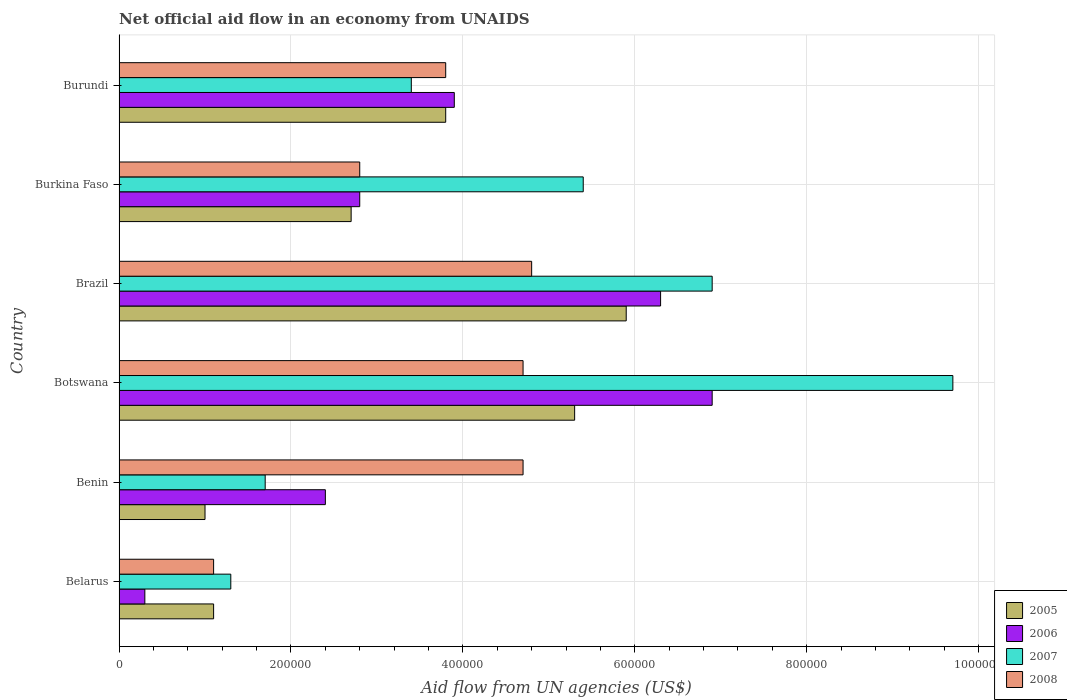How many groups of bars are there?
Offer a terse response. 6. How many bars are there on the 6th tick from the top?
Your response must be concise. 4. What is the label of the 3rd group of bars from the top?
Make the answer very short. Brazil. What is the net official aid flow in 2007 in Belarus?
Provide a short and direct response. 1.30e+05. Across all countries, what is the maximum net official aid flow in 2006?
Provide a succinct answer. 6.90e+05. In which country was the net official aid flow in 2006 maximum?
Offer a terse response. Botswana. In which country was the net official aid flow in 2008 minimum?
Make the answer very short. Belarus. What is the total net official aid flow in 2007 in the graph?
Make the answer very short. 2.84e+06. What is the difference between the net official aid flow in 2006 in Benin and that in Brazil?
Give a very brief answer. -3.90e+05. What is the difference between the net official aid flow in 2008 and net official aid flow in 2007 in Botswana?
Your response must be concise. -5.00e+05. What is the ratio of the net official aid flow in 2006 in Belarus to that in Burundi?
Provide a succinct answer. 0.08. Is the net official aid flow in 2006 in Botswana less than that in Burkina Faso?
Offer a terse response. No. What is the difference between the highest and the lowest net official aid flow in 2007?
Offer a very short reply. 8.40e+05. In how many countries, is the net official aid flow in 2006 greater than the average net official aid flow in 2006 taken over all countries?
Ensure brevity in your answer.  3. Is the sum of the net official aid flow in 2006 in Belarus and Benin greater than the maximum net official aid flow in 2005 across all countries?
Keep it short and to the point. No. Is it the case that in every country, the sum of the net official aid flow in 2007 and net official aid flow in 2006 is greater than the sum of net official aid flow in 2005 and net official aid flow in 2008?
Your answer should be compact. No. What does the 4th bar from the top in Belarus represents?
Ensure brevity in your answer.  2005. Is it the case that in every country, the sum of the net official aid flow in 2006 and net official aid flow in 2005 is greater than the net official aid flow in 2008?
Provide a short and direct response. No. How many bars are there?
Make the answer very short. 24. What is the difference between two consecutive major ticks on the X-axis?
Your answer should be compact. 2.00e+05. Are the values on the major ticks of X-axis written in scientific E-notation?
Keep it short and to the point. No. Does the graph contain any zero values?
Your answer should be very brief. No. How many legend labels are there?
Give a very brief answer. 4. What is the title of the graph?
Your answer should be very brief. Net official aid flow in an economy from UNAIDS. What is the label or title of the X-axis?
Your answer should be very brief. Aid flow from UN agencies (US$). What is the label or title of the Y-axis?
Make the answer very short. Country. What is the Aid flow from UN agencies (US$) of 2005 in Benin?
Make the answer very short. 1.00e+05. What is the Aid flow from UN agencies (US$) in 2005 in Botswana?
Your answer should be compact. 5.30e+05. What is the Aid flow from UN agencies (US$) in 2006 in Botswana?
Ensure brevity in your answer.  6.90e+05. What is the Aid flow from UN agencies (US$) of 2007 in Botswana?
Ensure brevity in your answer.  9.70e+05. What is the Aid flow from UN agencies (US$) of 2005 in Brazil?
Make the answer very short. 5.90e+05. What is the Aid flow from UN agencies (US$) in 2006 in Brazil?
Provide a succinct answer. 6.30e+05. What is the Aid flow from UN agencies (US$) in 2007 in Brazil?
Give a very brief answer. 6.90e+05. What is the Aid flow from UN agencies (US$) of 2007 in Burkina Faso?
Make the answer very short. 5.40e+05. What is the Aid flow from UN agencies (US$) in 2005 in Burundi?
Your response must be concise. 3.80e+05. What is the Aid flow from UN agencies (US$) in 2006 in Burundi?
Your answer should be very brief. 3.90e+05. What is the Aid flow from UN agencies (US$) of 2008 in Burundi?
Your response must be concise. 3.80e+05. Across all countries, what is the maximum Aid flow from UN agencies (US$) in 2005?
Provide a succinct answer. 5.90e+05. Across all countries, what is the maximum Aid flow from UN agencies (US$) in 2006?
Keep it short and to the point. 6.90e+05. Across all countries, what is the maximum Aid flow from UN agencies (US$) in 2007?
Provide a succinct answer. 9.70e+05. Across all countries, what is the minimum Aid flow from UN agencies (US$) in 2005?
Make the answer very short. 1.00e+05. Across all countries, what is the minimum Aid flow from UN agencies (US$) in 2007?
Your answer should be compact. 1.30e+05. What is the total Aid flow from UN agencies (US$) of 2005 in the graph?
Your answer should be very brief. 1.98e+06. What is the total Aid flow from UN agencies (US$) of 2006 in the graph?
Offer a very short reply. 2.26e+06. What is the total Aid flow from UN agencies (US$) of 2007 in the graph?
Your answer should be very brief. 2.84e+06. What is the total Aid flow from UN agencies (US$) in 2008 in the graph?
Your answer should be very brief. 2.19e+06. What is the difference between the Aid flow from UN agencies (US$) in 2005 in Belarus and that in Benin?
Offer a very short reply. 10000. What is the difference between the Aid flow from UN agencies (US$) in 2007 in Belarus and that in Benin?
Provide a short and direct response. -4.00e+04. What is the difference between the Aid flow from UN agencies (US$) of 2008 in Belarus and that in Benin?
Offer a terse response. -3.60e+05. What is the difference between the Aid flow from UN agencies (US$) in 2005 in Belarus and that in Botswana?
Offer a terse response. -4.20e+05. What is the difference between the Aid flow from UN agencies (US$) of 2006 in Belarus and that in Botswana?
Provide a short and direct response. -6.60e+05. What is the difference between the Aid flow from UN agencies (US$) of 2007 in Belarus and that in Botswana?
Your response must be concise. -8.40e+05. What is the difference between the Aid flow from UN agencies (US$) in 2008 in Belarus and that in Botswana?
Give a very brief answer. -3.60e+05. What is the difference between the Aid flow from UN agencies (US$) in 2005 in Belarus and that in Brazil?
Your answer should be very brief. -4.80e+05. What is the difference between the Aid flow from UN agencies (US$) of 2006 in Belarus and that in Brazil?
Give a very brief answer. -6.00e+05. What is the difference between the Aid flow from UN agencies (US$) of 2007 in Belarus and that in Brazil?
Make the answer very short. -5.60e+05. What is the difference between the Aid flow from UN agencies (US$) of 2008 in Belarus and that in Brazil?
Ensure brevity in your answer.  -3.70e+05. What is the difference between the Aid flow from UN agencies (US$) of 2005 in Belarus and that in Burkina Faso?
Offer a very short reply. -1.60e+05. What is the difference between the Aid flow from UN agencies (US$) of 2006 in Belarus and that in Burkina Faso?
Provide a succinct answer. -2.50e+05. What is the difference between the Aid flow from UN agencies (US$) of 2007 in Belarus and that in Burkina Faso?
Provide a short and direct response. -4.10e+05. What is the difference between the Aid flow from UN agencies (US$) in 2008 in Belarus and that in Burkina Faso?
Your answer should be compact. -1.70e+05. What is the difference between the Aid flow from UN agencies (US$) in 2005 in Belarus and that in Burundi?
Offer a terse response. -2.70e+05. What is the difference between the Aid flow from UN agencies (US$) of 2006 in Belarus and that in Burundi?
Keep it short and to the point. -3.60e+05. What is the difference between the Aid flow from UN agencies (US$) in 2007 in Belarus and that in Burundi?
Your answer should be very brief. -2.10e+05. What is the difference between the Aid flow from UN agencies (US$) of 2008 in Belarus and that in Burundi?
Your response must be concise. -2.70e+05. What is the difference between the Aid flow from UN agencies (US$) in 2005 in Benin and that in Botswana?
Provide a short and direct response. -4.30e+05. What is the difference between the Aid flow from UN agencies (US$) in 2006 in Benin and that in Botswana?
Provide a succinct answer. -4.50e+05. What is the difference between the Aid flow from UN agencies (US$) of 2007 in Benin and that in Botswana?
Provide a short and direct response. -8.00e+05. What is the difference between the Aid flow from UN agencies (US$) of 2005 in Benin and that in Brazil?
Provide a short and direct response. -4.90e+05. What is the difference between the Aid flow from UN agencies (US$) of 2006 in Benin and that in Brazil?
Your answer should be very brief. -3.90e+05. What is the difference between the Aid flow from UN agencies (US$) of 2007 in Benin and that in Brazil?
Give a very brief answer. -5.20e+05. What is the difference between the Aid flow from UN agencies (US$) in 2007 in Benin and that in Burkina Faso?
Keep it short and to the point. -3.70e+05. What is the difference between the Aid flow from UN agencies (US$) in 2008 in Benin and that in Burkina Faso?
Provide a succinct answer. 1.90e+05. What is the difference between the Aid flow from UN agencies (US$) of 2005 in Benin and that in Burundi?
Ensure brevity in your answer.  -2.80e+05. What is the difference between the Aid flow from UN agencies (US$) in 2006 in Botswana and that in Brazil?
Provide a succinct answer. 6.00e+04. What is the difference between the Aid flow from UN agencies (US$) of 2008 in Botswana and that in Burkina Faso?
Offer a terse response. 1.90e+05. What is the difference between the Aid flow from UN agencies (US$) in 2005 in Botswana and that in Burundi?
Ensure brevity in your answer.  1.50e+05. What is the difference between the Aid flow from UN agencies (US$) of 2007 in Botswana and that in Burundi?
Provide a short and direct response. 6.30e+05. What is the difference between the Aid flow from UN agencies (US$) in 2008 in Botswana and that in Burundi?
Ensure brevity in your answer.  9.00e+04. What is the difference between the Aid flow from UN agencies (US$) of 2005 in Brazil and that in Burkina Faso?
Ensure brevity in your answer.  3.20e+05. What is the difference between the Aid flow from UN agencies (US$) in 2007 in Brazil and that in Burkina Faso?
Provide a succinct answer. 1.50e+05. What is the difference between the Aid flow from UN agencies (US$) in 2005 in Brazil and that in Burundi?
Your answer should be compact. 2.10e+05. What is the difference between the Aid flow from UN agencies (US$) in 2007 in Brazil and that in Burundi?
Ensure brevity in your answer.  3.50e+05. What is the difference between the Aid flow from UN agencies (US$) in 2005 in Burkina Faso and that in Burundi?
Your answer should be very brief. -1.10e+05. What is the difference between the Aid flow from UN agencies (US$) in 2005 in Belarus and the Aid flow from UN agencies (US$) in 2006 in Benin?
Offer a terse response. -1.30e+05. What is the difference between the Aid flow from UN agencies (US$) of 2005 in Belarus and the Aid flow from UN agencies (US$) of 2007 in Benin?
Offer a very short reply. -6.00e+04. What is the difference between the Aid flow from UN agencies (US$) of 2005 in Belarus and the Aid flow from UN agencies (US$) of 2008 in Benin?
Offer a very short reply. -3.60e+05. What is the difference between the Aid flow from UN agencies (US$) of 2006 in Belarus and the Aid flow from UN agencies (US$) of 2008 in Benin?
Keep it short and to the point. -4.40e+05. What is the difference between the Aid flow from UN agencies (US$) in 2005 in Belarus and the Aid flow from UN agencies (US$) in 2006 in Botswana?
Offer a very short reply. -5.80e+05. What is the difference between the Aid flow from UN agencies (US$) in 2005 in Belarus and the Aid flow from UN agencies (US$) in 2007 in Botswana?
Provide a succinct answer. -8.60e+05. What is the difference between the Aid flow from UN agencies (US$) of 2005 in Belarus and the Aid flow from UN agencies (US$) of 2008 in Botswana?
Your answer should be very brief. -3.60e+05. What is the difference between the Aid flow from UN agencies (US$) in 2006 in Belarus and the Aid flow from UN agencies (US$) in 2007 in Botswana?
Provide a succinct answer. -9.40e+05. What is the difference between the Aid flow from UN agencies (US$) in 2006 in Belarus and the Aid flow from UN agencies (US$) in 2008 in Botswana?
Offer a terse response. -4.40e+05. What is the difference between the Aid flow from UN agencies (US$) of 2007 in Belarus and the Aid flow from UN agencies (US$) of 2008 in Botswana?
Provide a succinct answer. -3.40e+05. What is the difference between the Aid flow from UN agencies (US$) in 2005 in Belarus and the Aid flow from UN agencies (US$) in 2006 in Brazil?
Provide a succinct answer. -5.20e+05. What is the difference between the Aid flow from UN agencies (US$) of 2005 in Belarus and the Aid flow from UN agencies (US$) of 2007 in Brazil?
Offer a very short reply. -5.80e+05. What is the difference between the Aid flow from UN agencies (US$) in 2005 in Belarus and the Aid flow from UN agencies (US$) in 2008 in Brazil?
Your answer should be very brief. -3.70e+05. What is the difference between the Aid flow from UN agencies (US$) in 2006 in Belarus and the Aid flow from UN agencies (US$) in 2007 in Brazil?
Offer a terse response. -6.60e+05. What is the difference between the Aid flow from UN agencies (US$) of 2006 in Belarus and the Aid flow from UN agencies (US$) of 2008 in Brazil?
Provide a short and direct response. -4.50e+05. What is the difference between the Aid flow from UN agencies (US$) in 2007 in Belarus and the Aid flow from UN agencies (US$) in 2008 in Brazil?
Provide a succinct answer. -3.50e+05. What is the difference between the Aid flow from UN agencies (US$) in 2005 in Belarus and the Aid flow from UN agencies (US$) in 2007 in Burkina Faso?
Offer a very short reply. -4.30e+05. What is the difference between the Aid flow from UN agencies (US$) in 2005 in Belarus and the Aid flow from UN agencies (US$) in 2008 in Burkina Faso?
Your response must be concise. -1.70e+05. What is the difference between the Aid flow from UN agencies (US$) in 2006 in Belarus and the Aid flow from UN agencies (US$) in 2007 in Burkina Faso?
Your response must be concise. -5.10e+05. What is the difference between the Aid flow from UN agencies (US$) of 2006 in Belarus and the Aid flow from UN agencies (US$) of 2008 in Burkina Faso?
Make the answer very short. -2.50e+05. What is the difference between the Aid flow from UN agencies (US$) of 2005 in Belarus and the Aid flow from UN agencies (US$) of 2006 in Burundi?
Offer a very short reply. -2.80e+05. What is the difference between the Aid flow from UN agencies (US$) in 2005 in Belarus and the Aid flow from UN agencies (US$) in 2008 in Burundi?
Make the answer very short. -2.70e+05. What is the difference between the Aid flow from UN agencies (US$) in 2006 in Belarus and the Aid flow from UN agencies (US$) in 2007 in Burundi?
Make the answer very short. -3.10e+05. What is the difference between the Aid flow from UN agencies (US$) in 2006 in Belarus and the Aid flow from UN agencies (US$) in 2008 in Burundi?
Provide a succinct answer. -3.50e+05. What is the difference between the Aid flow from UN agencies (US$) in 2005 in Benin and the Aid flow from UN agencies (US$) in 2006 in Botswana?
Your answer should be compact. -5.90e+05. What is the difference between the Aid flow from UN agencies (US$) in 2005 in Benin and the Aid flow from UN agencies (US$) in 2007 in Botswana?
Your response must be concise. -8.70e+05. What is the difference between the Aid flow from UN agencies (US$) in 2005 in Benin and the Aid flow from UN agencies (US$) in 2008 in Botswana?
Ensure brevity in your answer.  -3.70e+05. What is the difference between the Aid flow from UN agencies (US$) in 2006 in Benin and the Aid flow from UN agencies (US$) in 2007 in Botswana?
Provide a succinct answer. -7.30e+05. What is the difference between the Aid flow from UN agencies (US$) of 2005 in Benin and the Aid flow from UN agencies (US$) of 2006 in Brazil?
Your response must be concise. -5.30e+05. What is the difference between the Aid flow from UN agencies (US$) of 2005 in Benin and the Aid flow from UN agencies (US$) of 2007 in Brazil?
Offer a very short reply. -5.90e+05. What is the difference between the Aid flow from UN agencies (US$) in 2005 in Benin and the Aid flow from UN agencies (US$) in 2008 in Brazil?
Your answer should be very brief. -3.80e+05. What is the difference between the Aid flow from UN agencies (US$) in 2006 in Benin and the Aid flow from UN agencies (US$) in 2007 in Brazil?
Provide a succinct answer. -4.50e+05. What is the difference between the Aid flow from UN agencies (US$) in 2006 in Benin and the Aid flow from UN agencies (US$) in 2008 in Brazil?
Offer a terse response. -2.40e+05. What is the difference between the Aid flow from UN agencies (US$) of 2007 in Benin and the Aid flow from UN agencies (US$) of 2008 in Brazil?
Your answer should be very brief. -3.10e+05. What is the difference between the Aid flow from UN agencies (US$) in 2005 in Benin and the Aid flow from UN agencies (US$) in 2006 in Burkina Faso?
Offer a very short reply. -1.80e+05. What is the difference between the Aid flow from UN agencies (US$) in 2005 in Benin and the Aid flow from UN agencies (US$) in 2007 in Burkina Faso?
Offer a very short reply. -4.40e+05. What is the difference between the Aid flow from UN agencies (US$) in 2005 in Benin and the Aid flow from UN agencies (US$) in 2008 in Burkina Faso?
Your answer should be very brief. -1.80e+05. What is the difference between the Aid flow from UN agencies (US$) of 2006 in Benin and the Aid flow from UN agencies (US$) of 2007 in Burkina Faso?
Give a very brief answer. -3.00e+05. What is the difference between the Aid flow from UN agencies (US$) in 2006 in Benin and the Aid flow from UN agencies (US$) in 2008 in Burkina Faso?
Your answer should be compact. -4.00e+04. What is the difference between the Aid flow from UN agencies (US$) of 2005 in Benin and the Aid flow from UN agencies (US$) of 2008 in Burundi?
Give a very brief answer. -2.80e+05. What is the difference between the Aid flow from UN agencies (US$) of 2006 in Benin and the Aid flow from UN agencies (US$) of 2007 in Burundi?
Make the answer very short. -1.00e+05. What is the difference between the Aid flow from UN agencies (US$) of 2005 in Botswana and the Aid flow from UN agencies (US$) of 2006 in Brazil?
Your response must be concise. -1.00e+05. What is the difference between the Aid flow from UN agencies (US$) in 2005 in Botswana and the Aid flow from UN agencies (US$) in 2007 in Brazil?
Provide a short and direct response. -1.60e+05. What is the difference between the Aid flow from UN agencies (US$) in 2005 in Botswana and the Aid flow from UN agencies (US$) in 2008 in Brazil?
Offer a very short reply. 5.00e+04. What is the difference between the Aid flow from UN agencies (US$) in 2006 in Botswana and the Aid flow from UN agencies (US$) in 2007 in Brazil?
Offer a terse response. 0. What is the difference between the Aid flow from UN agencies (US$) of 2006 in Botswana and the Aid flow from UN agencies (US$) of 2008 in Brazil?
Make the answer very short. 2.10e+05. What is the difference between the Aid flow from UN agencies (US$) of 2005 in Botswana and the Aid flow from UN agencies (US$) of 2007 in Burkina Faso?
Provide a succinct answer. -10000. What is the difference between the Aid flow from UN agencies (US$) of 2005 in Botswana and the Aid flow from UN agencies (US$) of 2008 in Burkina Faso?
Make the answer very short. 2.50e+05. What is the difference between the Aid flow from UN agencies (US$) of 2006 in Botswana and the Aid flow from UN agencies (US$) of 2007 in Burkina Faso?
Offer a terse response. 1.50e+05. What is the difference between the Aid flow from UN agencies (US$) in 2007 in Botswana and the Aid flow from UN agencies (US$) in 2008 in Burkina Faso?
Your answer should be compact. 6.90e+05. What is the difference between the Aid flow from UN agencies (US$) in 2005 in Botswana and the Aid flow from UN agencies (US$) in 2008 in Burundi?
Ensure brevity in your answer.  1.50e+05. What is the difference between the Aid flow from UN agencies (US$) of 2006 in Botswana and the Aid flow from UN agencies (US$) of 2008 in Burundi?
Your answer should be compact. 3.10e+05. What is the difference between the Aid flow from UN agencies (US$) in 2007 in Botswana and the Aid flow from UN agencies (US$) in 2008 in Burundi?
Provide a succinct answer. 5.90e+05. What is the difference between the Aid flow from UN agencies (US$) in 2006 in Brazil and the Aid flow from UN agencies (US$) in 2008 in Burkina Faso?
Your response must be concise. 3.50e+05. What is the difference between the Aid flow from UN agencies (US$) of 2005 in Brazil and the Aid flow from UN agencies (US$) of 2008 in Burundi?
Keep it short and to the point. 2.10e+05. What is the difference between the Aid flow from UN agencies (US$) of 2005 in Burkina Faso and the Aid flow from UN agencies (US$) of 2007 in Burundi?
Keep it short and to the point. -7.00e+04. What is the difference between the Aid flow from UN agencies (US$) in 2005 in Burkina Faso and the Aid flow from UN agencies (US$) in 2008 in Burundi?
Ensure brevity in your answer.  -1.10e+05. What is the difference between the Aid flow from UN agencies (US$) of 2007 in Burkina Faso and the Aid flow from UN agencies (US$) of 2008 in Burundi?
Your response must be concise. 1.60e+05. What is the average Aid flow from UN agencies (US$) in 2006 per country?
Provide a short and direct response. 3.77e+05. What is the average Aid flow from UN agencies (US$) in 2007 per country?
Your answer should be compact. 4.73e+05. What is the average Aid flow from UN agencies (US$) of 2008 per country?
Offer a terse response. 3.65e+05. What is the difference between the Aid flow from UN agencies (US$) of 2006 and Aid flow from UN agencies (US$) of 2007 in Belarus?
Make the answer very short. -1.00e+05. What is the difference between the Aid flow from UN agencies (US$) in 2005 and Aid flow from UN agencies (US$) in 2006 in Benin?
Your answer should be compact. -1.40e+05. What is the difference between the Aid flow from UN agencies (US$) in 2005 and Aid flow from UN agencies (US$) in 2008 in Benin?
Your response must be concise. -3.70e+05. What is the difference between the Aid flow from UN agencies (US$) of 2007 and Aid flow from UN agencies (US$) of 2008 in Benin?
Make the answer very short. -3.00e+05. What is the difference between the Aid flow from UN agencies (US$) of 2005 and Aid flow from UN agencies (US$) of 2007 in Botswana?
Provide a succinct answer. -4.40e+05. What is the difference between the Aid flow from UN agencies (US$) of 2005 and Aid flow from UN agencies (US$) of 2008 in Botswana?
Offer a terse response. 6.00e+04. What is the difference between the Aid flow from UN agencies (US$) in 2006 and Aid flow from UN agencies (US$) in 2007 in Botswana?
Offer a very short reply. -2.80e+05. What is the difference between the Aid flow from UN agencies (US$) in 2006 and Aid flow from UN agencies (US$) in 2008 in Botswana?
Your response must be concise. 2.20e+05. What is the difference between the Aid flow from UN agencies (US$) of 2005 and Aid flow from UN agencies (US$) of 2006 in Brazil?
Offer a terse response. -4.00e+04. What is the difference between the Aid flow from UN agencies (US$) in 2005 and Aid flow from UN agencies (US$) in 2008 in Brazil?
Provide a short and direct response. 1.10e+05. What is the difference between the Aid flow from UN agencies (US$) in 2006 and Aid flow from UN agencies (US$) in 2007 in Brazil?
Keep it short and to the point. -6.00e+04. What is the difference between the Aid flow from UN agencies (US$) of 2007 and Aid flow from UN agencies (US$) of 2008 in Brazil?
Make the answer very short. 2.10e+05. What is the difference between the Aid flow from UN agencies (US$) of 2005 and Aid flow from UN agencies (US$) of 2006 in Burkina Faso?
Ensure brevity in your answer.  -10000. What is the difference between the Aid flow from UN agencies (US$) of 2006 and Aid flow from UN agencies (US$) of 2007 in Burkina Faso?
Ensure brevity in your answer.  -2.60e+05. What is the difference between the Aid flow from UN agencies (US$) of 2006 and Aid flow from UN agencies (US$) of 2008 in Burkina Faso?
Offer a very short reply. 0. What is the difference between the Aid flow from UN agencies (US$) of 2007 and Aid flow from UN agencies (US$) of 2008 in Burkina Faso?
Make the answer very short. 2.60e+05. What is the difference between the Aid flow from UN agencies (US$) of 2005 and Aid flow from UN agencies (US$) of 2006 in Burundi?
Offer a very short reply. -10000. What is the difference between the Aid flow from UN agencies (US$) of 2006 and Aid flow from UN agencies (US$) of 2007 in Burundi?
Offer a terse response. 5.00e+04. What is the difference between the Aid flow from UN agencies (US$) in 2006 and Aid flow from UN agencies (US$) in 2008 in Burundi?
Your response must be concise. 10000. What is the ratio of the Aid flow from UN agencies (US$) of 2006 in Belarus to that in Benin?
Your answer should be very brief. 0.12. What is the ratio of the Aid flow from UN agencies (US$) in 2007 in Belarus to that in Benin?
Keep it short and to the point. 0.76. What is the ratio of the Aid flow from UN agencies (US$) of 2008 in Belarus to that in Benin?
Keep it short and to the point. 0.23. What is the ratio of the Aid flow from UN agencies (US$) of 2005 in Belarus to that in Botswana?
Your response must be concise. 0.21. What is the ratio of the Aid flow from UN agencies (US$) of 2006 in Belarus to that in Botswana?
Your response must be concise. 0.04. What is the ratio of the Aid flow from UN agencies (US$) in 2007 in Belarus to that in Botswana?
Make the answer very short. 0.13. What is the ratio of the Aid flow from UN agencies (US$) in 2008 in Belarus to that in Botswana?
Offer a terse response. 0.23. What is the ratio of the Aid flow from UN agencies (US$) in 2005 in Belarus to that in Brazil?
Give a very brief answer. 0.19. What is the ratio of the Aid flow from UN agencies (US$) in 2006 in Belarus to that in Brazil?
Your answer should be very brief. 0.05. What is the ratio of the Aid flow from UN agencies (US$) in 2007 in Belarus to that in Brazil?
Your answer should be compact. 0.19. What is the ratio of the Aid flow from UN agencies (US$) in 2008 in Belarus to that in Brazil?
Offer a very short reply. 0.23. What is the ratio of the Aid flow from UN agencies (US$) of 2005 in Belarus to that in Burkina Faso?
Provide a short and direct response. 0.41. What is the ratio of the Aid flow from UN agencies (US$) of 2006 in Belarus to that in Burkina Faso?
Make the answer very short. 0.11. What is the ratio of the Aid flow from UN agencies (US$) in 2007 in Belarus to that in Burkina Faso?
Offer a very short reply. 0.24. What is the ratio of the Aid flow from UN agencies (US$) of 2008 in Belarus to that in Burkina Faso?
Provide a short and direct response. 0.39. What is the ratio of the Aid flow from UN agencies (US$) in 2005 in Belarus to that in Burundi?
Your answer should be compact. 0.29. What is the ratio of the Aid flow from UN agencies (US$) in 2006 in Belarus to that in Burundi?
Your answer should be compact. 0.08. What is the ratio of the Aid flow from UN agencies (US$) of 2007 in Belarus to that in Burundi?
Your answer should be very brief. 0.38. What is the ratio of the Aid flow from UN agencies (US$) of 2008 in Belarus to that in Burundi?
Give a very brief answer. 0.29. What is the ratio of the Aid flow from UN agencies (US$) in 2005 in Benin to that in Botswana?
Offer a terse response. 0.19. What is the ratio of the Aid flow from UN agencies (US$) in 2006 in Benin to that in Botswana?
Provide a succinct answer. 0.35. What is the ratio of the Aid flow from UN agencies (US$) in 2007 in Benin to that in Botswana?
Provide a short and direct response. 0.18. What is the ratio of the Aid flow from UN agencies (US$) in 2005 in Benin to that in Brazil?
Ensure brevity in your answer.  0.17. What is the ratio of the Aid flow from UN agencies (US$) of 2006 in Benin to that in Brazil?
Provide a short and direct response. 0.38. What is the ratio of the Aid flow from UN agencies (US$) of 2007 in Benin to that in Brazil?
Make the answer very short. 0.25. What is the ratio of the Aid flow from UN agencies (US$) of 2008 in Benin to that in Brazil?
Provide a short and direct response. 0.98. What is the ratio of the Aid flow from UN agencies (US$) in 2005 in Benin to that in Burkina Faso?
Your answer should be compact. 0.37. What is the ratio of the Aid flow from UN agencies (US$) of 2007 in Benin to that in Burkina Faso?
Keep it short and to the point. 0.31. What is the ratio of the Aid flow from UN agencies (US$) in 2008 in Benin to that in Burkina Faso?
Ensure brevity in your answer.  1.68. What is the ratio of the Aid flow from UN agencies (US$) of 2005 in Benin to that in Burundi?
Your response must be concise. 0.26. What is the ratio of the Aid flow from UN agencies (US$) in 2006 in Benin to that in Burundi?
Your response must be concise. 0.62. What is the ratio of the Aid flow from UN agencies (US$) in 2008 in Benin to that in Burundi?
Make the answer very short. 1.24. What is the ratio of the Aid flow from UN agencies (US$) in 2005 in Botswana to that in Brazil?
Offer a very short reply. 0.9. What is the ratio of the Aid flow from UN agencies (US$) in 2006 in Botswana to that in Brazil?
Your answer should be very brief. 1.1. What is the ratio of the Aid flow from UN agencies (US$) of 2007 in Botswana to that in Brazil?
Offer a very short reply. 1.41. What is the ratio of the Aid flow from UN agencies (US$) of 2008 in Botswana to that in Brazil?
Give a very brief answer. 0.98. What is the ratio of the Aid flow from UN agencies (US$) of 2005 in Botswana to that in Burkina Faso?
Give a very brief answer. 1.96. What is the ratio of the Aid flow from UN agencies (US$) in 2006 in Botswana to that in Burkina Faso?
Offer a terse response. 2.46. What is the ratio of the Aid flow from UN agencies (US$) in 2007 in Botswana to that in Burkina Faso?
Provide a short and direct response. 1.8. What is the ratio of the Aid flow from UN agencies (US$) in 2008 in Botswana to that in Burkina Faso?
Offer a very short reply. 1.68. What is the ratio of the Aid flow from UN agencies (US$) of 2005 in Botswana to that in Burundi?
Ensure brevity in your answer.  1.39. What is the ratio of the Aid flow from UN agencies (US$) in 2006 in Botswana to that in Burundi?
Keep it short and to the point. 1.77. What is the ratio of the Aid flow from UN agencies (US$) in 2007 in Botswana to that in Burundi?
Offer a terse response. 2.85. What is the ratio of the Aid flow from UN agencies (US$) in 2008 in Botswana to that in Burundi?
Ensure brevity in your answer.  1.24. What is the ratio of the Aid flow from UN agencies (US$) in 2005 in Brazil to that in Burkina Faso?
Offer a very short reply. 2.19. What is the ratio of the Aid flow from UN agencies (US$) in 2006 in Brazil to that in Burkina Faso?
Offer a very short reply. 2.25. What is the ratio of the Aid flow from UN agencies (US$) of 2007 in Brazil to that in Burkina Faso?
Give a very brief answer. 1.28. What is the ratio of the Aid flow from UN agencies (US$) in 2008 in Brazil to that in Burkina Faso?
Ensure brevity in your answer.  1.71. What is the ratio of the Aid flow from UN agencies (US$) of 2005 in Brazil to that in Burundi?
Ensure brevity in your answer.  1.55. What is the ratio of the Aid flow from UN agencies (US$) of 2006 in Brazil to that in Burundi?
Give a very brief answer. 1.62. What is the ratio of the Aid flow from UN agencies (US$) in 2007 in Brazil to that in Burundi?
Provide a succinct answer. 2.03. What is the ratio of the Aid flow from UN agencies (US$) of 2008 in Brazil to that in Burundi?
Provide a succinct answer. 1.26. What is the ratio of the Aid flow from UN agencies (US$) in 2005 in Burkina Faso to that in Burundi?
Make the answer very short. 0.71. What is the ratio of the Aid flow from UN agencies (US$) of 2006 in Burkina Faso to that in Burundi?
Your answer should be very brief. 0.72. What is the ratio of the Aid flow from UN agencies (US$) in 2007 in Burkina Faso to that in Burundi?
Ensure brevity in your answer.  1.59. What is the ratio of the Aid flow from UN agencies (US$) of 2008 in Burkina Faso to that in Burundi?
Offer a terse response. 0.74. What is the difference between the highest and the second highest Aid flow from UN agencies (US$) of 2005?
Offer a terse response. 6.00e+04. What is the difference between the highest and the second highest Aid flow from UN agencies (US$) of 2006?
Ensure brevity in your answer.  6.00e+04. What is the difference between the highest and the second highest Aid flow from UN agencies (US$) of 2008?
Your response must be concise. 10000. What is the difference between the highest and the lowest Aid flow from UN agencies (US$) in 2005?
Offer a very short reply. 4.90e+05. What is the difference between the highest and the lowest Aid flow from UN agencies (US$) in 2006?
Your response must be concise. 6.60e+05. What is the difference between the highest and the lowest Aid flow from UN agencies (US$) of 2007?
Make the answer very short. 8.40e+05. What is the difference between the highest and the lowest Aid flow from UN agencies (US$) in 2008?
Ensure brevity in your answer.  3.70e+05. 